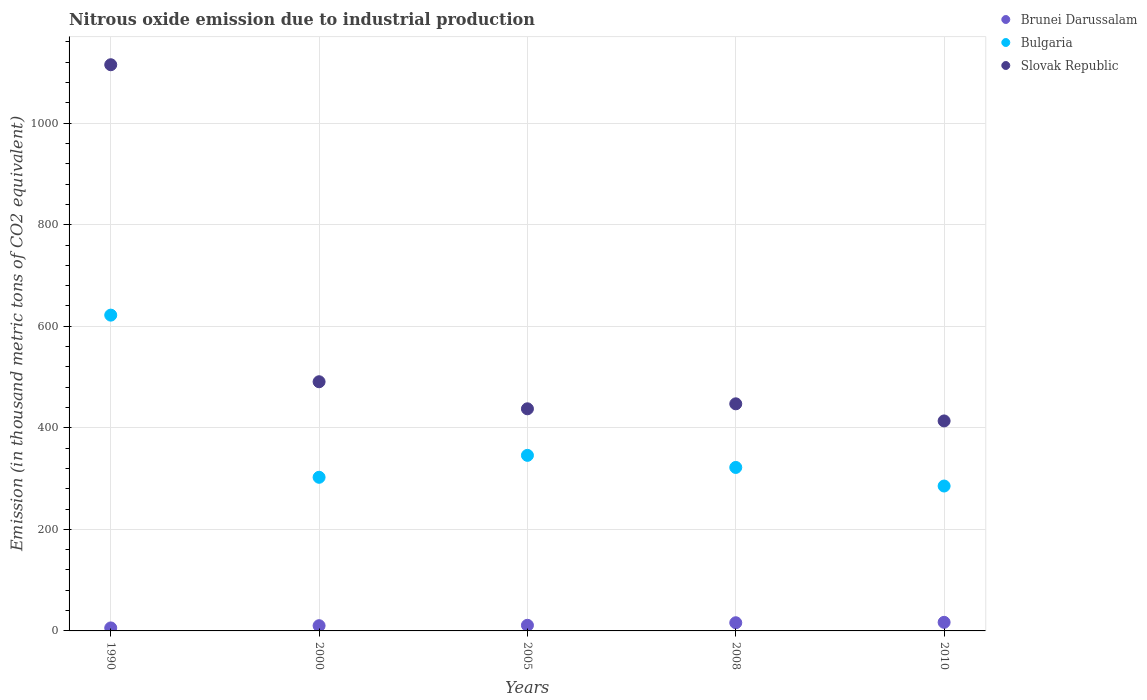How many different coloured dotlines are there?
Offer a terse response. 3. What is the amount of nitrous oxide emitted in Brunei Darussalam in 2005?
Your answer should be very brief. 11.1. Across all years, what is the maximum amount of nitrous oxide emitted in Slovak Republic?
Give a very brief answer. 1115.2. Across all years, what is the minimum amount of nitrous oxide emitted in Slovak Republic?
Your answer should be very brief. 413.6. What is the total amount of nitrous oxide emitted in Brunei Darussalam in the graph?
Give a very brief answer. 60.3. What is the difference between the amount of nitrous oxide emitted in Slovak Republic in 2000 and that in 2005?
Offer a very short reply. 53.3. What is the difference between the amount of nitrous oxide emitted in Bulgaria in 2005 and the amount of nitrous oxide emitted in Brunei Darussalam in 2010?
Provide a succinct answer. 328.9. What is the average amount of nitrous oxide emitted in Slovak Republic per year?
Make the answer very short. 580.88. In the year 2005, what is the difference between the amount of nitrous oxide emitted in Bulgaria and amount of nitrous oxide emitted in Slovak Republic?
Your answer should be compact. -91.7. In how many years, is the amount of nitrous oxide emitted in Bulgaria greater than 680 thousand metric tons?
Provide a short and direct response. 0. What is the ratio of the amount of nitrous oxide emitted in Brunei Darussalam in 2008 to that in 2010?
Provide a short and direct response. 0.95. Is the difference between the amount of nitrous oxide emitted in Bulgaria in 2005 and 2010 greater than the difference between the amount of nitrous oxide emitted in Slovak Republic in 2005 and 2010?
Keep it short and to the point. Yes. What is the difference between the highest and the second highest amount of nitrous oxide emitted in Brunei Darussalam?
Provide a short and direct response. 0.8. What is the difference between the highest and the lowest amount of nitrous oxide emitted in Bulgaria?
Provide a succinct answer. 336.6. In how many years, is the amount of nitrous oxide emitted in Brunei Darussalam greater than the average amount of nitrous oxide emitted in Brunei Darussalam taken over all years?
Provide a succinct answer. 2. Is the sum of the amount of nitrous oxide emitted in Slovak Republic in 1990 and 2005 greater than the maximum amount of nitrous oxide emitted in Bulgaria across all years?
Provide a short and direct response. Yes. Is it the case that in every year, the sum of the amount of nitrous oxide emitted in Brunei Darussalam and amount of nitrous oxide emitted in Slovak Republic  is greater than the amount of nitrous oxide emitted in Bulgaria?
Your response must be concise. Yes. Does the amount of nitrous oxide emitted in Brunei Darussalam monotonically increase over the years?
Offer a terse response. Yes. Is the amount of nitrous oxide emitted in Bulgaria strictly less than the amount of nitrous oxide emitted in Slovak Republic over the years?
Offer a terse response. Yes. How many years are there in the graph?
Offer a terse response. 5. Does the graph contain any zero values?
Keep it short and to the point. No. Does the graph contain grids?
Offer a terse response. Yes. How are the legend labels stacked?
Give a very brief answer. Vertical. What is the title of the graph?
Your answer should be compact. Nitrous oxide emission due to industrial production. Does "Andorra" appear as one of the legend labels in the graph?
Offer a terse response. No. What is the label or title of the Y-axis?
Offer a terse response. Emission (in thousand metric tons of CO2 equivalent). What is the Emission (in thousand metric tons of CO2 equivalent) in Bulgaria in 1990?
Provide a short and direct response. 622. What is the Emission (in thousand metric tons of CO2 equivalent) of Slovak Republic in 1990?
Provide a succinct answer. 1115.2. What is the Emission (in thousand metric tons of CO2 equivalent) in Brunei Darussalam in 2000?
Offer a very short reply. 10.3. What is the Emission (in thousand metric tons of CO2 equivalent) in Bulgaria in 2000?
Provide a succinct answer. 302.6. What is the Emission (in thousand metric tons of CO2 equivalent) of Slovak Republic in 2000?
Your response must be concise. 490.8. What is the Emission (in thousand metric tons of CO2 equivalent) of Brunei Darussalam in 2005?
Your response must be concise. 11.1. What is the Emission (in thousand metric tons of CO2 equivalent) in Bulgaria in 2005?
Offer a very short reply. 345.8. What is the Emission (in thousand metric tons of CO2 equivalent) of Slovak Republic in 2005?
Offer a terse response. 437.5. What is the Emission (in thousand metric tons of CO2 equivalent) in Bulgaria in 2008?
Keep it short and to the point. 322. What is the Emission (in thousand metric tons of CO2 equivalent) in Slovak Republic in 2008?
Give a very brief answer. 447.3. What is the Emission (in thousand metric tons of CO2 equivalent) in Bulgaria in 2010?
Offer a very short reply. 285.4. What is the Emission (in thousand metric tons of CO2 equivalent) of Slovak Republic in 2010?
Ensure brevity in your answer.  413.6. Across all years, what is the maximum Emission (in thousand metric tons of CO2 equivalent) of Bulgaria?
Your response must be concise. 622. Across all years, what is the maximum Emission (in thousand metric tons of CO2 equivalent) of Slovak Republic?
Your response must be concise. 1115.2. Across all years, what is the minimum Emission (in thousand metric tons of CO2 equivalent) in Brunei Darussalam?
Give a very brief answer. 5.9. Across all years, what is the minimum Emission (in thousand metric tons of CO2 equivalent) in Bulgaria?
Offer a terse response. 285.4. Across all years, what is the minimum Emission (in thousand metric tons of CO2 equivalent) of Slovak Republic?
Your answer should be compact. 413.6. What is the total Emission (in thousand metric tons of CO2 equivalent) of Brunei Darussalam in the graph?
Your response must be concise. 60.3. What is the total Emission (in thousand metric tons of CO2 equivalent) in Bulgaria in the graph?
Give a very brief answer. 1877.8. What is the total Emission (in thousand metric tons of CO2 equivalent) in Slovak Republic in the graph?
Offer a very short reply. 2904.4. What is the difference between the Emission (in thousand metric tons of CO2 equivalent) in Bulgaria in 1990 and that in 2000?
Provide a short and direct response. 319.4. What is the difference between the Emission (in thousand metric tons of CO2 equivalent) in Slovak Republic in 1990 and that in 2000?
Give a very brief answer. 624.4. What is the difference between the Emission (in thousand metric tons of CO2 equivalent) in Brunei Darussalam in 1990 and that in 2005?
Your response must be concise. -5.2. What is the difference between the Emission (in thousand metric tons of CO2 equivalent) in Bulgaria in 1990 and that in 2005?
Give a very brief answer. 276.2. What is the difference between the Emission (in thousand metric tons of CO2 equivalent) in Slovak Republic in 1990 and that in 2005?
Ensure brevity in your answer.  677.7. What is the difference between the Emission (in thousand metric tons of CO2 equivalent) of Brunei Darussalam in 1990 and that in 2008?
Your answer should be compact. -10.2. What is the difference between the Emission (in thousand metric tons of CO2 equivalent) in Bulgaria in 1990 and that in 2008?
Provide a short and direct response. 300. What is the difference between the Emission (in thousand metric tons of CO2 equivalent) in Slovak Republic in 1990 and that in 2008?
Ensure brevity in your answer.  667.9. What is the difference between the Emission (in thousand metric tons of CO2 equivalent) in Brunei Darussalam in 1990 and that in 2010?
Give a very brief answer. -11. What is the difference between the Emission (in thousand metric tons of CO2 equivalent) of Bulgaria in 1990 and that in 2010?
Your answer should be compact. 336.6. What is the difference between the Emission (in thousand metric tons of CO2 equivalent) of Slovak Republic in 1990 and that in 2010?
Your answer should be very brief. 701.6. What is the difference between the Emission (in thousand metric tons of CO2 equivalent) in Brunei Darussalam in 2000 and that in 2005?
Ensure brevity in your answer.  -0.8. What is the difference between the Emission (in thousand metric tons of CO2 equivalent) of Bulgaria in 2000 and that in 2005?
Offer a terse response. -43.2. What is the difference between the Emission (in thousand metric tons of CO2 equivalent) of Slovak Republic in 2000 and that in 2005?
Your response must be concise. 53.3. What is the difference between the Emission (in thousand metric tons of CO2 equivalent) in Brunei Darussalam in 2000 and that in 2008?
Keep it short and to the point. -5.8. What is the difference between the Emission (in thousand metric tons of CO2 equivalent) of Bulgaria in 2000 and that in 2008?
Ensure brevity in your answer.  -19.4. What is the difference between the Emission (in thousand metric tons of CO2 equivalent) of Slovak Republic in 2000 and that in 2008?
Your answer should be compact. 43.5. What is the difference between the Emission (in thousand metric tons of CO2 equivalent) in Slovak Republic in 2000 and that in 2010?
Ensure brevity in your answer.  77.2. What is the difference between the Emission (in thousand metric tons of CO2 equivalent) of Brunei Darussalam in 2005 and that in 2008?
Provide a succinct answer. -5. What is the difference between the Emission (in thousand metric tons of CO2 equivalent) of Bulgaria in 2005 and that in 2008?
Your answer should be compact. 23.8. What is the difference between the Emission (in thousand metric tons of CO2 equivalent) in Bulgaria in 2005 and that in 2010?
Keep it short and to the point. 60.4. What is the difference between the Emission (in thousand metric tons of CO2 equivalent) of Slovak Republic in 2005 and that in 2010?
Make the answer very short. 23.9. What is the difference between the Emission (in thousand metric tons of CO2 equivalent) of Brunei Darussalam in 2008 and that in 2010?
Provide a short and direct response. -0.8. What is the difference between the Emission (in thousand metric tons of CO2 equivalent) in Bulgaria in 2008 and that in 2010?
Offer a very short reply. 36.6. What is the difference between the Emission (in thousand metric tons of CO2 equivalent) in Slovak Republic in 2008 and that in 2010?
Keep it short and to the point. 33.7. What is the difference between the Emission (in thousand metric tons of CO2 equivalent) of Brunei Darussalam in 1990 and the Emission (in thousand metric tons of CO2 equivalent) of Bulgaria in 2000?
Provide a short and direct response. -296.7. What is the difference between the Emission (in thousand metric tons of CO2 equivalent) in Brunei Darussalam in 1990 and the Emission (in thousand metric tons of CO2 equivalent) in Slovak Republic in 2000?
Provide a short and direct response. -484.9. What is the difference between the Emission (in thousand metric tons of CO2 equivalent) of Bulgaria in 1990 and the Emission (in thousand metric tons of CO2 equivalent) of Slovak Republic in 2000?
Provide a succinct answer. 131.2. What is the difference between the Emission (in thousand metric tons of CO2 equivalent) in Brunei Darussalam in 1990 and the Emission (in thousand metric tons of CO2 equivalent) in Bulgaria in 2005?
Offer a terse response. -339.9. What is the difference between the Emission (in thousand metric tons of CO2 equivalent) of Brunei Darussalam in 1990 and the Emission (in thousand metric tons of CO2 equivalent) of Slovak Republic in 2005?
Offer a terse response. -431.6. What is the difference between the Emission (in thousand metric tons of CO2 equivalent) in Bulgaria in 1990 and the Emission (in thousand metric tons of CO2 equivalent) in Slovak Republic in 2005?
Provide a succinct answer. 184.5. What is the difference between the Emission (in thousand metric tons of CO2 equivalent) in Brunei Darussalam in 1990 and the Emission (in thousand metric tons of CO2 equivalent) in Bulgaria in 2008?
Offer a terse response. -316.1. What is the difference between the Emission (in thousand metric tons of CO2 equivalent) of Brunei Darussalam in 1990 and the Emission (in thousand metric tons of CO2 equivalent) of Slovak Republic in 2008?
Offer a very short reply. -441.4. What is the difference between the Emission (in thousand metric tons of CO2 equivalent) of Bulgaria in 1990 and the Emission (in thousand metric tons of CO2 equivalent) of Slovak Republic in 2008?
Provide a short and direct response. 174.7. What is the difference between the Emission (in thousand metric tons of CO2 equivalent) in Brunei Darussalam in 1990 and the Emission (in thousand metric tons of CO2 equivalent) in Bulgaria in 2010?
Offer a terse response. -279.5. What is the difference between the Emission (in thousand metric tons of CO2 equivalent) of Brunei Darussalam in 1990 and the Emission (in thousand metric tons of CO2 equivalent) of Slovak Republic in 2010?
Provide a succinct answer. -407.7. What is the difference between the Emission (in thousand metric tons of CO2 equivalent) in Bulgaria in 1990 and the Emission (in thousand metric tons of CO2 equivalent) in Slovak Republic in 2010?
Your response must be concise. 208.4. What is the difference between the Emission (in thousand metric tons of CO2 equivalent) in Brunei Darussalam in 2000 and the Emission (in thousand metric tons of CO2 equivalent) in Bulgaria in 2005?
Provide a short and direct response. -335.5. What is the difference between the Emission (in thousand metric tons of CO2 equivalent) in Brunei Darussalam in 2000 and the Emission (in thousand metric tons of CO2 equivalent) in Slovak Republic in 2005?
Offer a terse response. -427.2. What is the difference between the Emission (in thousand metric tons of CO2 equivalent) in Bulgaria in 2000 and the Emission (in thousand metric tons of CO2 equivalent) in Slovak Republic in 2005?
Give a very brief answer. -134.9. What is the difference between the Emission (in thousand metric tons of CO2 equivalent) in Brunei Darussalam in 2000 and the Emission (in thousand metric tons of CO2 equivalent) in Bulgaria in 2008?
Provide a short and direct response. -311.7. What is the difference between the Emission (in thousand metric tons of CO2 equivalent) in Brunei Darussalam in 2000 and the Emission (in thousand metric tons of CO2 equivalent) in Slovak Republic in 2008?
Offer a terse response. -437. What is the difference between the Emission (in thousand metric tons of CO2 equivalent) in Bulgaria in 2000 and the Emission (in thousand metric tons of CO2 equivalent) in Slovak Republic in 2008?
Ensure brevity in your answer.  -144.7. What is the difference between the Emission (in thousand metric tons of CO2 equivalent) of Brunei Darussalam in 2000 and the Emission (in thousand metric tons of CO2 equivalent) of Bulgaria in 2010?
Ensure brevity in your answer.  -275.1. What is the difference between the Emission (in thousand metric tons of CO2 equivalent) in Brunei Darussalam in 2000 and the Emission (in thousand metric tons of CO2 equivalent) in Slovak Republic in 2010?
Your answer should be compact. -403.3. What is the difference between the Emission (in thousand metric tons of CO2 equivalent) in Bulgaria in 2000 and the Emission (in thousand metric tons of CO2 equivalent) in Slovak Republic in 2010?
Your answer should be very brief. -111. What is the difference between the Emission (in thousand metric tons of CO2 equivalent) of Brunei Darussalam in 2005 and the Emission (in thousand metric tons of CO2 equivalent) of Bulgaria in 2008?
Ensure brevity in your answer.  -310.9. What is the difference between the Emission (in thousand metric tons of CO2 equivalent) of Brunei Darussalam in 2005 and the Emission (in thousand metric tons of CO2 equivalent) of Slovak Republic in 2008?
Make the answer very short. -436.2. What is the difference between the Emission (in thousand metric tons of CO2 equivalent) of Bulgaria in 2005 and the Emission (in thousand metric tons of CO2 equivalent) of Slovak Republic in 2008?
Your answer should be very brief. -101.5. What is the difference between the Emission (in thousand metric tons of CO2 equivalent) of Brunei Darussalam in 2005 and the Emission (in thousand metric tons of CO2 equivalent) of Bulgaria in 2010?
Offer a very short reply. -274.3. What is the difference between the Emission (in thousand metric tons of CO2 equivalent) of Brunei Darussalam in 2005 and the Emission (in thousand metric tons of CO2 equivalent) of Slovak Republic in 2010?
Your answer should be compact. -402.5. What is the difference between the Emission (in thousand metric tons of CO2 equivalent) of Bulgaria in 2005 and the Emission (in thousand metric tons of CO2 equivalent) of Slovak Republic in 2010?
Provide a short and direct response. -67.8. What is the difference between the Emission (in thousand metric tons of CO2 equivalent) of Brunei Darussalam in 2008 and the Emission (in thousand metric tons of CO2 equivalent) of Bulgaria in 2010?
Make the answer very short. -269.3. What is the difference between the Emission (in thousand metric tons of CO2 equivalent) of Brunei Darussalam in 2008 and the Emission (in thousand metric tons of CO2 equivalent) of Slovak Republic in 2010?
Your answer should be compact. -397.5. What is the difference between the Emission (in thousand metric tons of CO2 equivalent) of Bulgaria in 2008 and the Emission (in thousand metric tons of CO2 equivalent) of Slovak Republic in 2010?
Your answer should be compact. -91.6. What is the average Emission (in thousand metric tons of CO2 equivalent) of Brunei Darussalam per year?
Offer a terse response. 12.06. What is the average Emission (in thousand metric tons of CO2 equivalent) in Bulgaria per year?
Your answer should be compact. 375.56. What is the average Emission (in thousand metric tons of CO2 equivalent) in Slovak Republic per year?
Ensure brevity in your answer.  580.88. In the year 1990, what is the difference between the Emission (in thousand metric tons of CO2 equivalent) of Brunei Darussalam and Emission (in thousand metric tons of CO2 equivalent) of Bulgaria?
Your answer should be very brief. -616.1. In the year 1990, what is the difference between the Emission (in thousand metric tons of CO2 equivalent) of Brunei Darussalam and Emission (in thousand metric tons of CO2 equivalent) of Slovak Republic?
Your answer should be compact. -1109.3. In the year 1990, what is the difference between the Emission (in thousand metric tons of CO2 equivalent) of Bulgaria and Emission (in thousand metric tons of CO2 equivalent) of Slovak Republic?
Offer a terse response. -493.2. In the year 2000, what is the difference between the Emission (in thousand metric tons of CO2 equivalent) in Brunei Darussalam and Emission (in thousand metric tons of CO2 equivalent) in Bulgaria?
Give a very brief answer. -292.3. In the year 2000, what is the difference between the Emission (in thousand metric tons of CO2 equivalent) in Brunei Darussalam and Emission (in thousand metric tons of CO2 equivalent) in Slovak Republic?
Your answer should be compact. -480.5. In the year 2000, what is the difference between the Emission (in thousand metric tons of CO2 equivalent) in Bulgaria and Emission (in thousand metric tons of CO2 equivalent) in Slovak Republic?
Offer a very short reply. -188.2. In the year 2005, what is the difference between the Emission (in thousand metric tons of CO2 equivalent) of Brunei Darussalam and Emission (in thousand metric tons of CO2 equivalent) of Bulgaria?
Provide a succinct answer. -334.7. In the year 2005, what is the difference between the Emission (in thousand metric tons of CO2 equivalent) of Brunei Darussalam and Emission (in thousand metric tons of CO2 equivalent) of Slovak Republic?
Provide a short and direct response. -426.4. In the year 2005, what is the difference between the Emission (in thousand metric tons of CO2 equivalent) in Bulgaria and Emission (in thousand metric tons of CO2 equivalent) in Slovak Republic?
Your response must be concise. -91.7. In the year 2008, what is the difference between the Emission (in thousand metric tons of CO2 equivalent) of Brunei Darussalam and Emission (in thousand metric tons of CO2 equivalent) of Bulgaria?
Your answer should be very brief. -305.9. In the year 2008, what is the difference between the Emission (in thousand metric tons of CO2 equivalent) of Brunei Darussalam and Emission (in thousand metric tons of CO2 equivalent) of Slovak Republic?
Offer a very short reply. -431.2. In the year 2008, what is the difference between the Emission (in thousand metric tons of CO2 equivalent) of Bulgaria and Emission (in thousand metric tons of CO2 equivalent) of Slovak Republic?
Offer a terse response. -125.3. In the year 2010, what is the difference between the Emission (in thousand metric tons of CO2 equivalent) in Brunei Darussalam and Emission (in thousand metric tons of CO2 equivalent) in Bulgaria?
Provide a short and direct response. -268.5. In the year 2010, what is the difference between the Emission (in thousand metric tons of CO2 equivalent) in Brunei Darussalam and Emission (in thousand metric tons of CO2 equivalent) in Slovak Republic?
Offer a very short reply. -396.7. In the year 2010, what is the difference between the Emission (in thousand metric tons of CO2 equivalent) of Bulgaria and Emission (in thousand metric tons of CO2 equivalent) of Slovak Republic?
Your answer should be very brief. -128.2. What is the ratio of the Emission (in thousand metric tons of CO2 equivalent) in Brunei Darussalam in 1990 to that in 2000?
Your response must be concise. 0.57. What is the ratio of the Emission (in thousand metric tons of CO2 equivalent) of Bulgaria in 1990 to that in 2000?
Give a very brief answer. 2.06. What is the ratio of the Emission (in thousand metric tons of CO2 equivalent) in Slovak Republic in 1990 to that in 2000?
Ensure brevity in your answer.  2.27. What is the ratio of the Emission (in thousand metric tons of CO2 equivalent) of Brunei Darussalam in 1990 to that in 2005?
Keep it short and to the point. 0.53. What is the ratio of the Emission (in thousand metric tons of CO2 equivalent) in Bulgaria in 1990 to that in 2005?
Give a very brief answer. 1.8. What is the ratio of the Emission (in thousand metric tons of CO2 equivalent) of Slovak Republic in 1990 to that in 2005?
Give a very brief answer. 2.55. What is the ratio of the Emission (in thousand metric tons of CO2 equivalent) in Brunei Darussalam in 1990 to that in 2008?
Ensure brevity in your answer.  0.37. What is the ratio of the Emission (in thousand metric tons of CO2 equivalent) of Bulgaria in 1990 to that in 2008?
Your answer should be very brief. 1.93. What is the ratio of the Emission (in thousand metric tons of CO2 equivalent) in Slovak Republic in 1990 to that in 2008?
Your answer should be very brief. 2.49. What is the ratio of the Emission (in thousand metric tons of CO2 equivalent) in Brunei Darussalam in 1990 to that in 2010?
Make the answer very short. 0.35. What is the ratio of the Emission (in thousand metric tons of CO2 equivalent) of Bulgaria in 1990 to that in 2010?
Offer a terse response. 2.18. What is the ratio of the Emission (in thousand metric tons of CO2 equivalent) of Slovak Republic in 1990 to that in 2010?
Give a very brief answer. 2.7. What is the ratio of the Emission (in thousand metric tons of CO2 equivalent) of Brunei Darussalam in 2000 to that in 2005?
Offer a terse response. 0.93. What is the ratio of the Emission (in thousand metric tons of CO2 equivalent) in Bulgaria in 2000 to that in 2005?
Ensure brevity in your answer.  0.88. What is the ratio of the Emission (in thousand metric tons of CO2 equivalent) in Slovak Republic in 2000 to that in 2005?
Offer a very short reply. 1.12. What is the ratio of the Emission (in thousand metric tons of CO2 equivalent) in Brunei Darussalam in 2000 to that in 2008?
Make the answer very short. 0.64. What is the ratio of the Emission (in thousand metric tons of CO2 equivalent) of Bulgaria in 2000 to that in 2008?
Ensure brevity in your answer.  0.94. What is the ratio of the Emission (in thousand metric tons of CO2 equivalent) in Slovak Republic in 2000 to that in 2008?
Ensure brevity in your answer.  1.1. What is the ratio of the Emission (in thousand metric tons of CO2 equivalent) in Brunei Darussalam in 2000 to that in 2010?
Provide a succinct answer. 0.61. What is the ratio of the Emission (in thousand metric tons of CO2 equivalent) of Bulgaria in 2000 to that in 2010?
Your response must be concise. 1.06. What is the ratio of the Emission (in thousand metric tons of CO2 equivalent) of Slovak Republic in 2000 to that in 2010?
Keep it short and to the point. 1.19. What is the ratio of the Emission (in thousand metric tons of CO2 equivalent) of Brunei Darussalam in 2005 to that in 2008?
Your answer should be compact. 0.69. What is the ratio of the Emission (in thousand metric tons of CO2 equivalent) of Bulgaria in 2005 to that in 2008?
Your answer should be compact. 1.07. What is the ratio of the Emission (in thousand metric tons of CO2 equivalent) in Slovak Republic in 2005 to that in 2008?
Give a very brief answer. 0.98. What is the ratio of the Emission (in thousand metric tons of CO2 equivalent) in Brunei Darussalam in 2005 to that in 2010?
Keep it short and to the point. 0.66. What is the ratio of the Emission (in thousand metric tons of CO2 equivalent) in Bulgaria in 2005 to that in 2010?
Your answer should be very brief. 1.21. What is the ratio of the Emission (in thousand metric tons of CO2 equivalent) of Slovak Republic in 2005 to that in 2010?
Your answer should be very brief. 1.06. What is the ratio of the Emission (in thousand metric tons of CO2 equivalent) of Brunei Darussalam in 2008 to that in 2010?
Your response must be concise. 0.95. What is the ratio of the Emission (in thousand metric tons of CO2 equivalent) of Bulgaria in 2008 to that in 2010?
Keep it short and to the point. 1.13. What is the ratio of the Emission (in thousand metric tons of CO2 equivalent) in Slovak Republic in 2008 to that in 2010?
Your answer should be compact. 1.08. What is the difference between the highest and the second highest Emission (in thousand metric tons of CO2 equivalent) in Bulgaria?
Your answer should be very brief. 276.2. What is the difference between the highest and the second highest Emission (in thousand metric tons of CO2 equivalent) of Slovak Republic?
Make the answer very short. 624.4. What is the difference between the highest and the lowest Emission (in thousand metric tons of CO2 equivalent) of Bulgaria?
Offer a terse response. 336.6. What is the difference between the highest and the lowest Emission (in thousand metric tons of CO2 equivalent) of Slovak Republic?
Your answer should be very brief. 701.6. 